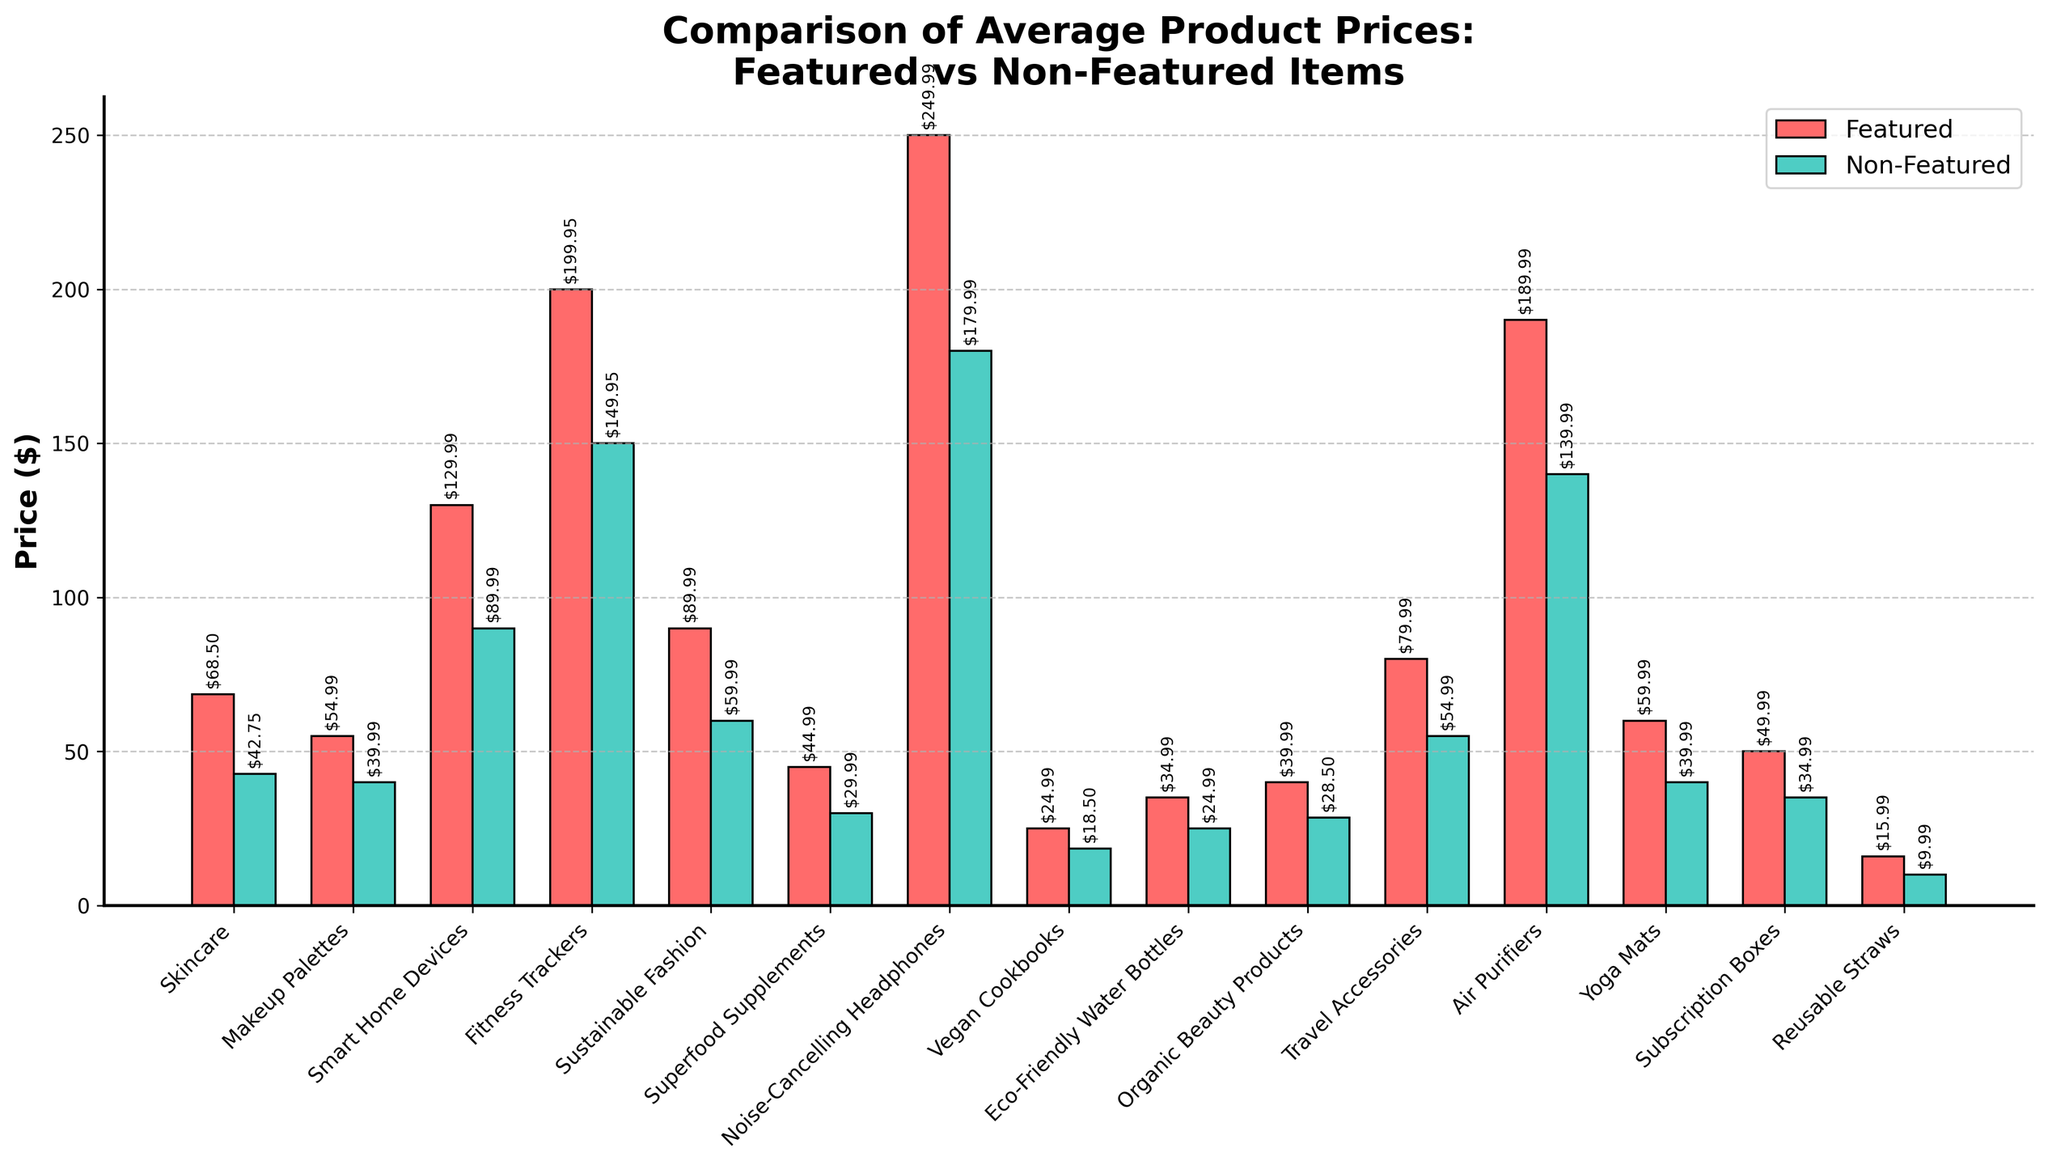Which category has the highest price difference between featured and non-featured items? To determine this, subtract the non-featured price from the featured price for each category, then compare these differences. Noise-Cancelling Headphones have the highest difference (249.99 - 179.99 = 70.00).
Answer: Noise-Cancelling Headphones Which category has the smallest price difference between featured and non-featured items? To determine this, subtract the non-featured price from the featured price for each category, then compare these differences. Reusable Straws have the smallest difference (15.99 - 9.99 = 6.00).
Answer: Reusable Straws How much more expensive, on average, are featured items compared to non-featured items across all categories? Calculate the difference (featured price - non-featured price) for each category, sum these differences, and divide by the number of categories. [(68.50 - 42.75) + (54.99 - 39.99) + (129.99 - 89.99) + (199.95 - 149.95) + (89.99 - 59.99) + (44.99 - 29.99) + (249.99 - 179.99) + (24.99 - 18.50) + (34.99 - 24.99) + (39.99 - 28.50) + (79.99 - 54.99) + (189.99 - 139.99) + (59.99 - 39.99) + (49.99 - 34.99) + (15.99 - 9.99)] / 15 = 30.33.
Answer: 30.33 Which category has the highest average price for featured items? Examine the height of the bars representing featured prices and identify the highest one. Noise-Cancelling Headphones have the highest featured price (249.99).
Answer: Noise-Cancelling Headphones Which category has the lowest non-featured price? Examine the height of the bars representing non-featured prices and identify the shortest one. Reusable Straws have the lowest non-featured price (9.99).
Answer: Reusable Straws Which item category shows the least price variance between featured and non-featured items visually by looking at the bar lengths? Identify the pair of bars (one red and one green) that appear closest in height. Reusable Straws have bars that are closest in height.
Answer: Reusable Straws Which category’s featured price is approximately double its non-featured price? Compare each pair of bars to identify where the featured price's bar is roughly twice as tall as the non-featured bar. Skincare approximately fits this criterion (68.50 is close to 2 * 42.75).
Answer: Skincare 